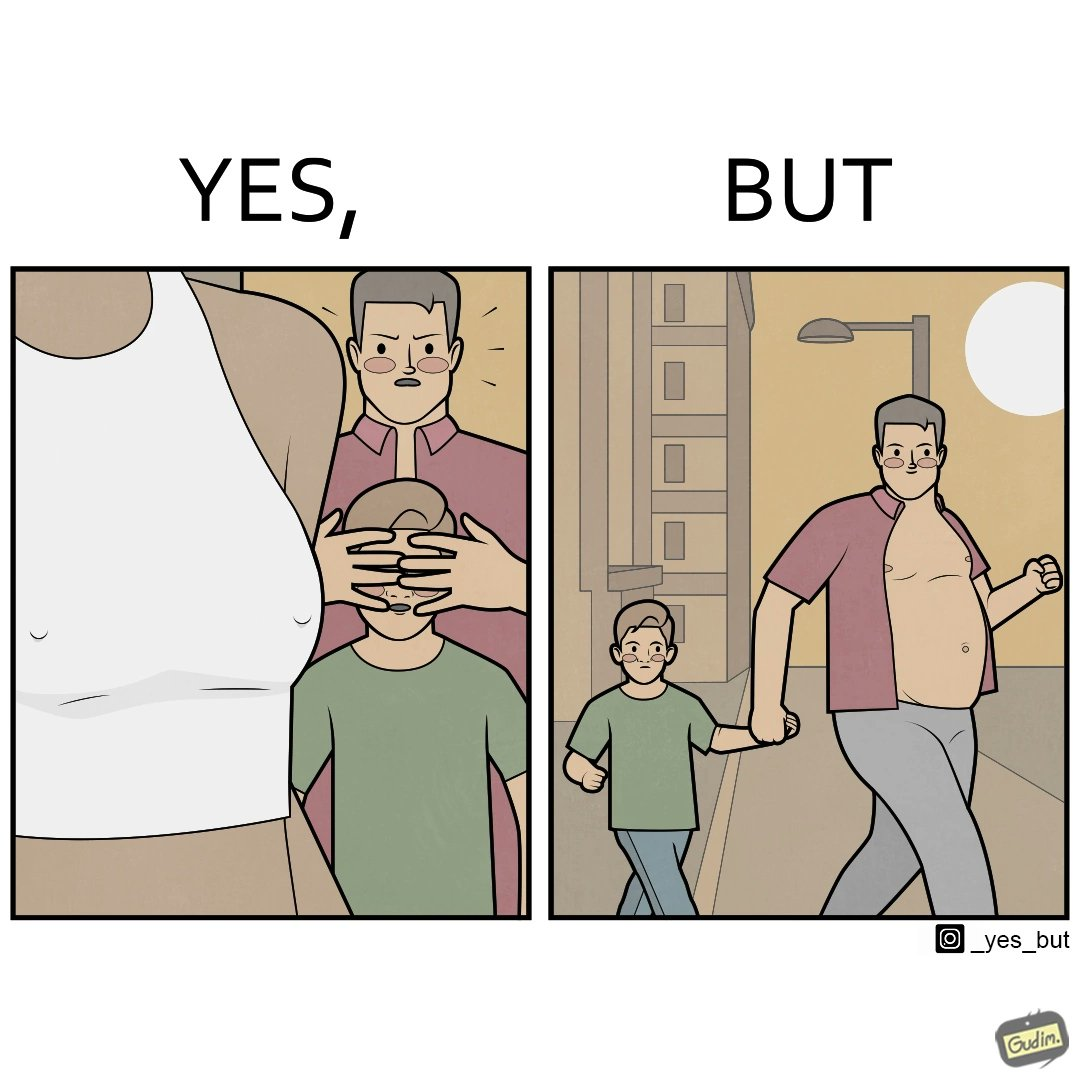What do you see in each half of this image? In the left part of the image: A father is hiding the eyes of his child so that he cannot see the private parts of women. In the right part of the image: The father is roaming with his children in shirt showing his body. 